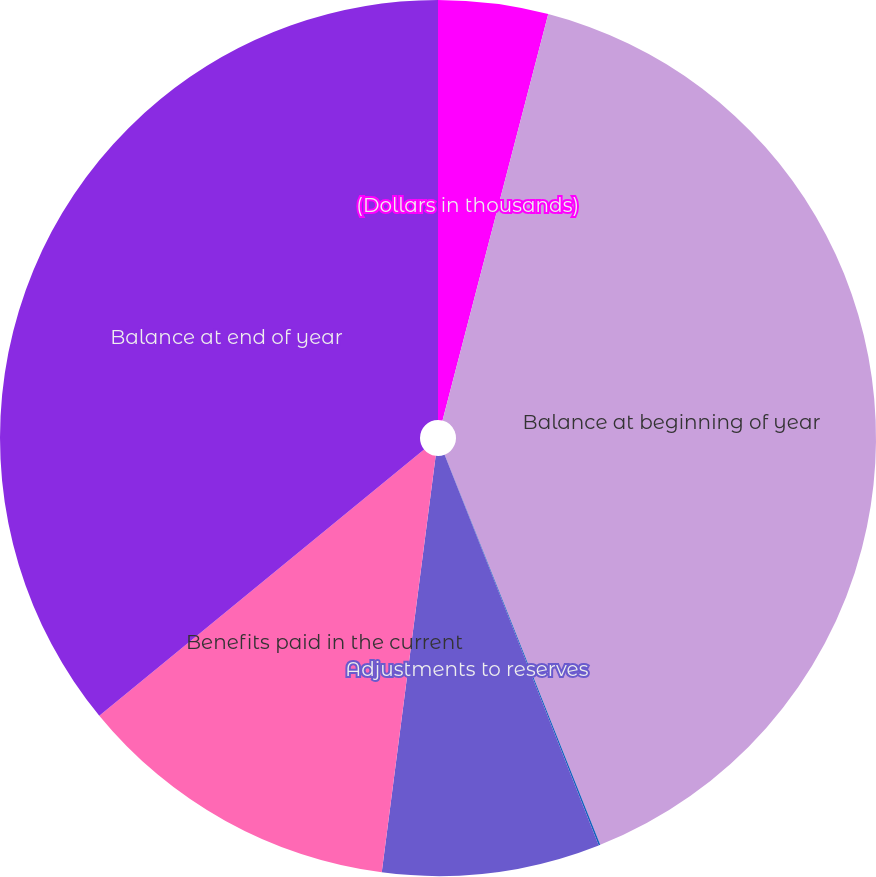<chart> <loc_0><loc_0><loc_500><loc_500><pie_chart><fcel>(Dollars in thousands)<fcel>Balance at beginning of year<fcel>Liabilities assumed<fcel>Adjustments to reserves<fcel>Benefits paid in the current<fcel>Balance at end of year<nl><fcel>4.05%<fcel>39.91%<fcel>0.06%<fcel>8.03%<fcel>12.02%<fcel>35.93%<nl></chart> 